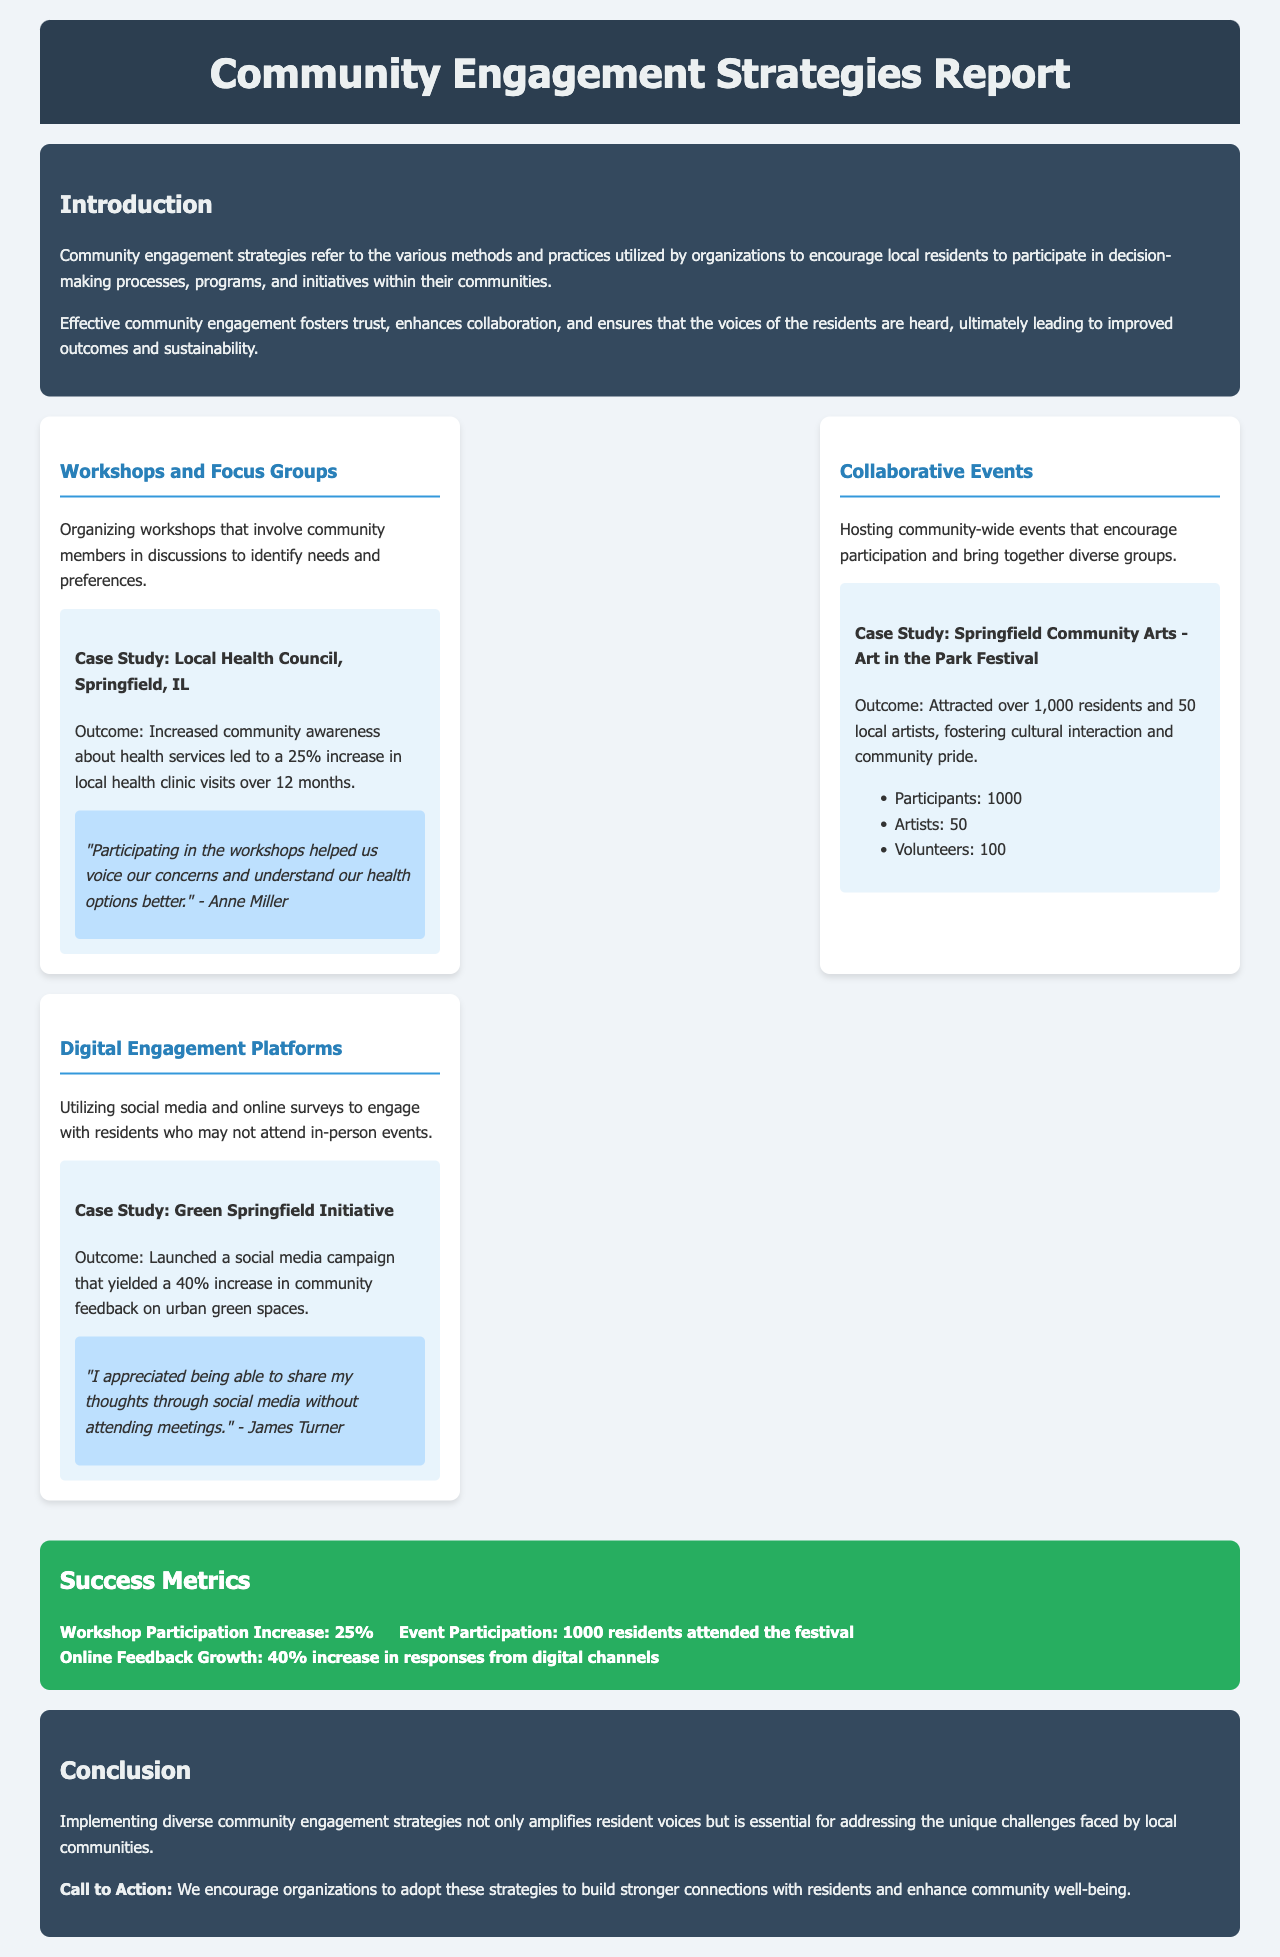What are community engagement strategies? Community engagement strategies are various methods and practices utilized by organizations to encourage local residents to participate in decision-making processes, programs, and initiatives.
Answer: Various methods and practices What was the outcome of the workshops organized by the Local Health Council? The outcome of the workshops led to a 25% increase in local health clinic visits over 12 months.
Answer: 25% increase How many residents attended the Art in the Park Festival? The report states that the event attracted over 1,000 residents.
Answer: 1000 residents What increase in community feedback was achieved through the social media campaign? The campaign yielded a 40% increase in community feedback on urban green spaces.
Answer: 40% increase Who provided a testimonial for the digital engagement strategy? The testimonial was provided by James Turner.
Answer: James Turner What was the total number of artists participating in the Art in the Park Festival? The festival featured 50 local artists.
Answer: 50 What type of events are hosted to foster cultural interaction? Collaborative events are hosted to encourage participation and bring together diverse groups.
Answer: Collaborative events What does the conclusion encourage organizations to do? The conclusion encourages organizations to adopt diverse community engagement strategies to build stronger connections with residents.
Answer: Adopt diverse strategies What style of report is this document presenting? This document presents a report on community engagement strategies with case studies and success metrics.
Answer: Report on community engagement strategies 